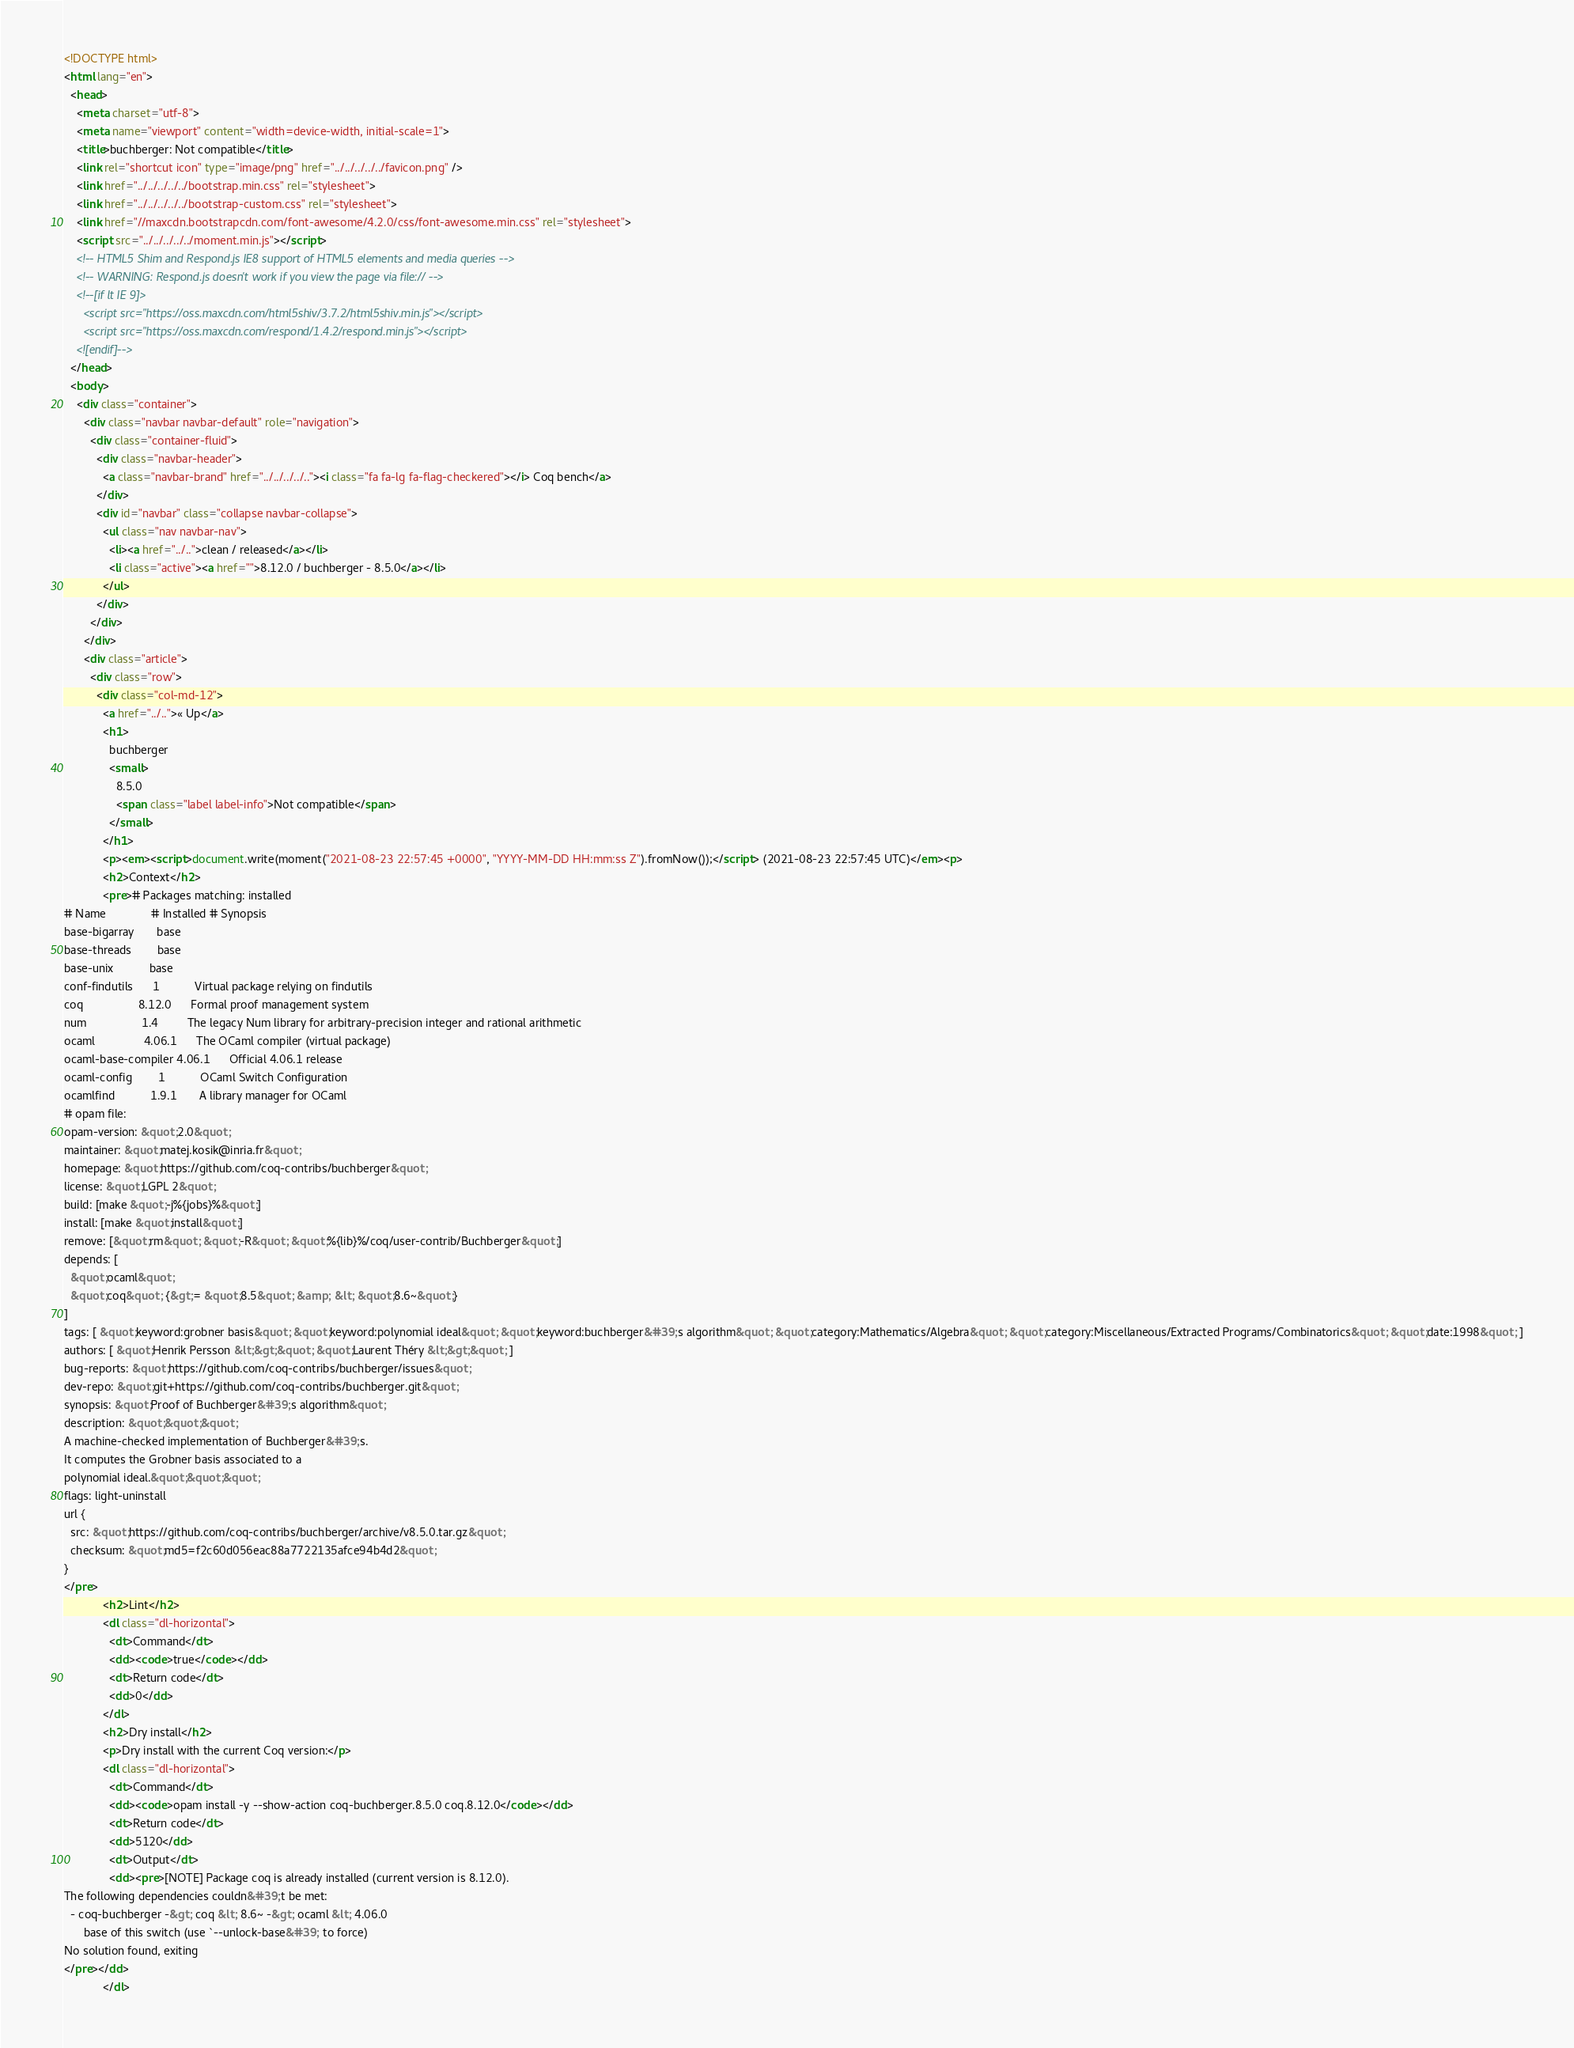Convert code to text. <code><loc_0><loc_0><loc_500><loc_500><_HTML_><!DOCTYPE html>
<html lang="en">
  <head>
    <meta charset="utf-8">
    <meta name="viewport" content="width=device-width, initial-scale=1">
    <title>buchberger: Not compatible</title>
    <link rel="shortcut icon" type="image/png" href="../../../../../favicon.png" />
    <link href="../../../../../bootstrap.min.css" rel="stylesheet">
    <link href="../../../../../bootstrap-custom.css" rel="stylesheet">
    <link href="//maxcdn.bootstrapcdn.com/font-awesome/4.2.0/css/font-awesome.min.css" rel="stylesheet">
    <script src="../../../../../moment.min.js"></script>
    <!-- HTML5 Shim and Respond.js IE8 support of HTML5 elements and media queries -->
    <!-- WARNING: Respond.js doesn't work if you view the page via file:// -->
    <!--[if lt IE 9]>
      <script src="https://oss.maxcdn.com/html5shiv/3.7.2/html5shiv.min.js"></script>
      <script src="https://oss.maxcdn.com/respond/1.4.2/respond.min.js"></script>
    <![endif]-->
  </head>
  <body>
    <div class="container">
      <div class="navbar navbar-default" role="navigation">
        <div class="container-fluid">
          <div class="navbar-header">
            <a class="navbar-brand" href="../../../../.."><i class="fa fa-lg fa-flag-checkered"></i> Coq bench</a>
          </div>
          <div id="navbar" class="collapse navbar-collapse">
            <ul class="nav navbar-nav">
              <li><a href="../..">clean / released</a></li>
              <li class="active"><a href="">8.12.0 / buchberger - 8.5.0</a></li>
            </ul>
          </div>
        </div>
      </div>
      <div class="article">
        <div class="row">
          <div class="col-md-12">
            <a href="../..">« Up</a>
            <h1>
              buchberger
              <small>
                8.5.0
                <span class="label label-info">Not compatible</span>
              </small>
            </h1>
            <p><em><script>document.write(moment("2021-08-23 22:57:45 +0000", "YYYY-MM-DD HH:mm:ss Z").fromNow());</script> (2021-08-23 22:57:45 UTC)</em><p>
            <h2>Context</h2>
            <pre># Packages matching: installed
# Name              # Installed # Synopsis
base-bigarray       base
base-threads        base
base-unix           base
conf-findutils      1           Virtual package relying on findutils
coq                 8.12.0      Formal proof management system
num                 1.4         The legacy Num library for arbitrary-precision integer and rational arithmetic
ocaml               4.06.1      The OCaml compiler (virtual package)
ocaml-base-compiler 4.06.1      Official 4.06.1 release
ocaml-config        1           OCaml Switch Configuration
ocamlfind           1.9.1       A library manager for OCaml
# opam file:
opam-version: &quot;2.0&quot;
maintainer: &quot;matej.kosik@inria.fr&quot;
homepage: &quot;https://github.com/coq-contribs/buchberger&quot;
license: &quot;LGPL 2&quot;
build: [make &quot;-j%{jobs}%&quot;]
install: [make &quot;install&quot;]
remove: [&quot;rm&quot; &quot;-R&quot; &quot;%{lib}%/coq/user-contrib/Buchberger&quot;]
depends: [
  &quot;ocaml&quot;
  &quot;coq&quot; {&gt;= &quot;8.5&quot; &amp; &lt; &quot;8.6~&quot;}
]
tags: [ &quot;keyword:grobner basis&quot; &quot;keyword:polynomial ideal&quot; &quot;keyword:buchberger&#39;s algorithm&quot; &quot;category:Mathematics/Algebra&quot; &quot;category:Miscellaneous/Extracted Programs/Combinatorics&quot; &quot;date:1998&quot; ]
authors: [ &quot;Henrik Persson &lt;&gt;&quot; &quot;Laurent Théry &lt;&gt;&quot; ]
bug-reports: &quot;https://github.com/coq-contribs/buchberger/issues&quot;
dev-repo: &quot;git+https://github.com/coq-contribs/buchberger.git&quot;
synopsis: &quot;Proof of Buchberger&#39;s algorithm&quot;
description: &quot;&quot;&quot;
A machine-checked implementation of Buchberger&#39;s.
It computes the Grobner basis associated to a
polynomial ideal.&quot;&quot;&quot;
flags: light-uninstall
url {
  src: &quot;https://github.com/coq-contribs/buchberger/archive/v8.5.0.tar.gz&quot;
  checksum: &quot;md5=f2c60d056eac88a7722135afce94b4d2&quot;
}
</pre>
            <h2>Lint</h2>
            <dl class="dl-horizontal">
              <dt>Command</dt>
              <dd><code>true</code></dd>
              <dt>Return code</dt>
              <dd>0</dd>
            </dl>
            <h2>Dry install</h2>
            <p>Dry install with the current Coq version:</p>
            <dl class="dl-horizontal">
              <dt>Command</dt>
              <dd><code>opam install -y --show-action coq-buchberger.8.5.0 coq.8.12.0</code></dd>
              <dt>Return code</dt>
              <dd>5120</dd>
              <dt>Output</dt>
              <dd><pre>[NOTE] Package coq is already installed (current version is 8.12.0).
The following dependencies couldn&#39;t be met:
  - coq-buchberger -&gt; coq &lt; 8.6~ -&gt; ocaml &lt; 4.06.0
      base of this switch (use `--unlock-base&#39; to force)
No solution found, exiting
</pre></dd>
            </dl></code> 